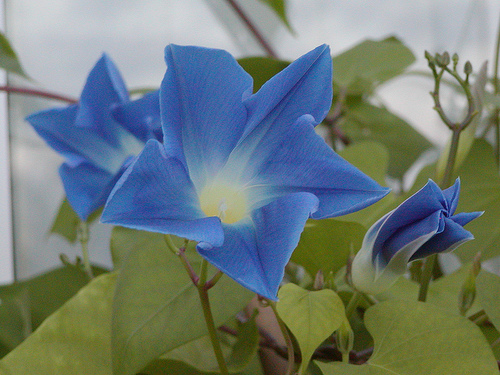<image>
Can you confirm if the flower is next to the flower? Yes. The flower is positioned adjacent to the flower, located nearby in the same general area. 